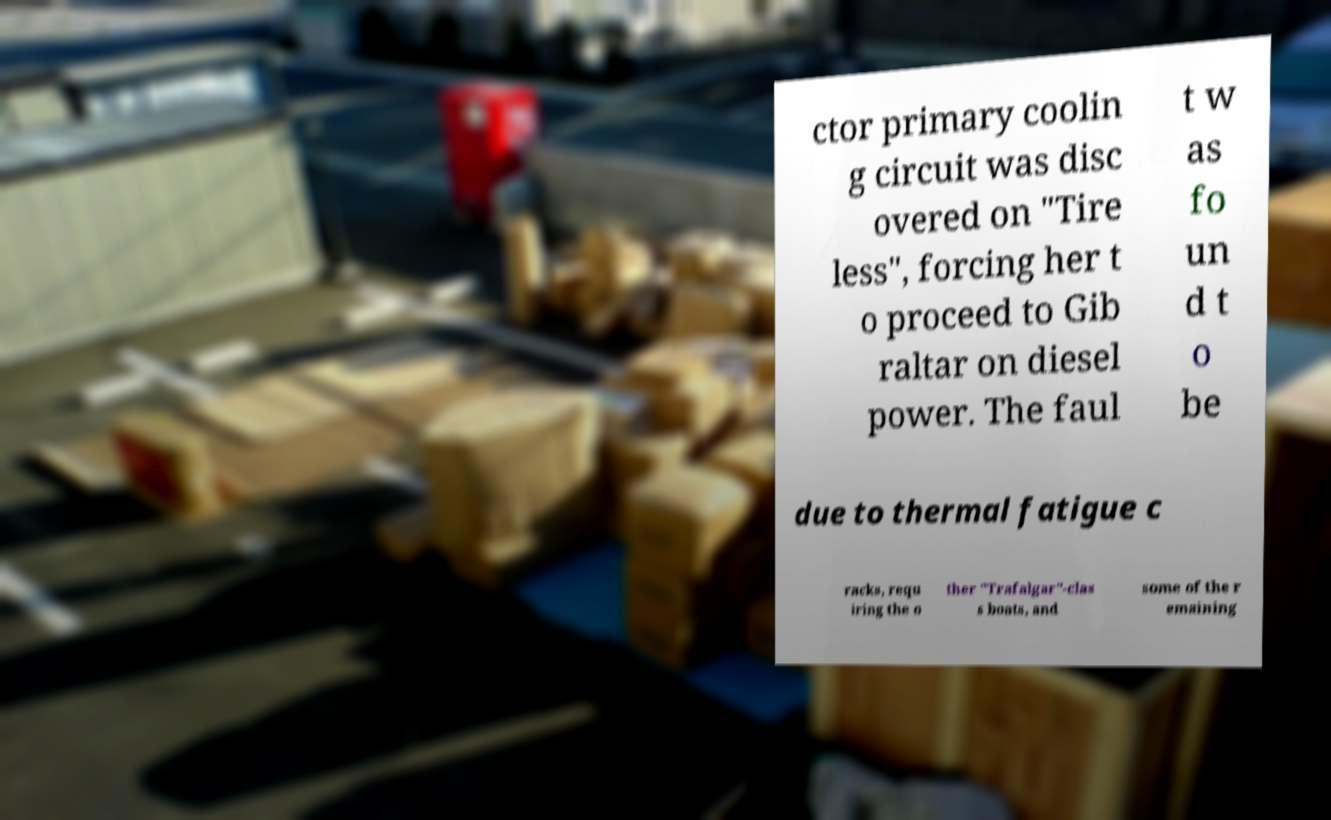There's text embedded in this image that I need extracted. Can you transcribe it verbatim? ctor primary coolin g circuit was disc overed on "Tire less", forcing her t o proceed to Gib raltar on diesel power. The faul t w as fo un d t o be due to thermal fatigue c racks, requ iring the o ther "Trafalgar"-clas s boats, and some of the r emaining 